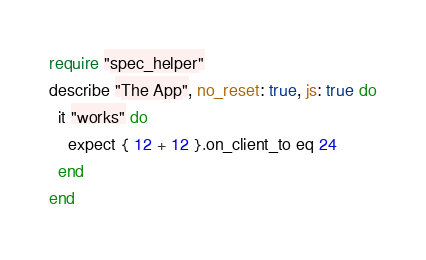<code> <loc_0><loc_0><loc_500><loc_500><_Ruby_>require "spec_helper"
describe "The App", no_reset: true, js: true do
  it "works" do
    expect { 12 + 12 }.on_client_to eq 24
  end
end
</code> 